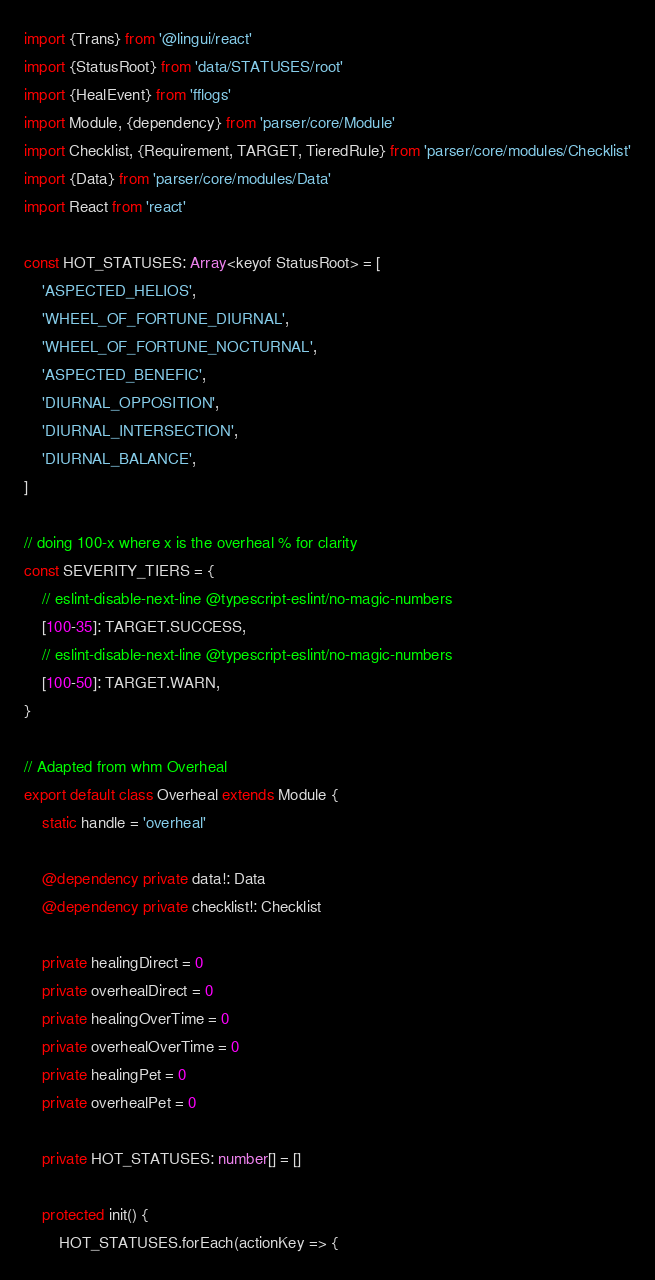<code> <loc_0><loc_0><loc_500><loc_500><_TypeScript_>import {Trans} from '@lingui/react'
import {StatusRoot} from 'data/STATUSES/root'
import {HealEvent} from 'fflogs'
import Module, {dependency} from 'parser/core/Module'
import Checklist, {Requirement, TARGET, TieredRule} from 'parser/core/modules/Checklist'
import {Data} from 'parser/core/modules/Data'
import React from 'react'

const HOT_STATUSES: Array<keyof StatusRoot> = [
	'ASPECTED_HELIOS',
	'WHEEL_OF_FORTUNE_DIURNAL',
	'WHEEL_OF_FORTUNE_NOCTURNAL',
	'ASPECTED_BENEFIC',
	'DIURNAL_OPPOSITION',
	'DIURNAL_INTERSECTION',
	'DIURNAL_BALANCE',
]

// doing 100-x where x is the overheal % for clarity
const SEVERITY_TIERS = {
	// eslint-disable-next-line @typescript-eslint/no-magic-numbers
	[100-35]: TARGET.SUCCESS,
	// eslint-disable-next-line @typescript-eslint/no-magic-numbers
	[100-50]: TARGET.WARN,
}

// Adapted from whm Overheal
export default class Overheal extends Module {
	static handle = 'overheal'

	@dependency private data!: Data
	@dependency private checklist!: Checklist

	private healingDirect = 0
	private overhealDirect = 0
	private healingOverTime = 0
	private overhealOverTime = 0
	private healingPet = 0
	private overhealPet = 0

	private HOT_STATUSES: number[] = []

	protected init() {
		HOT_STATUSES.forEach(actionKey => {</code> 